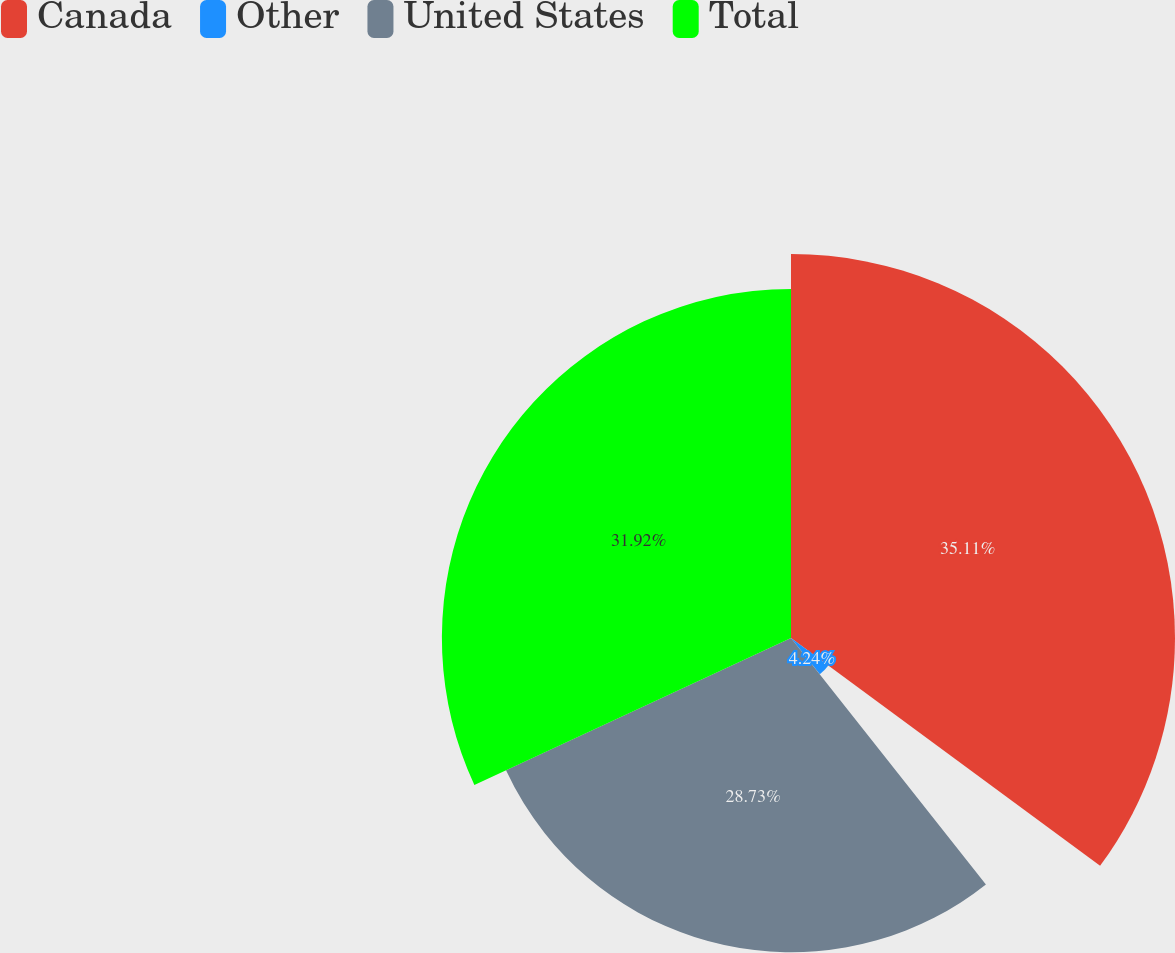Convert chart to OTSL. <chart><loc_0><loc_0><loc_500><loc_500><pie_chart><fcel>Canada<fcel>Other<fcel>United States<fcel>Total<nl><fcel>35.11%<fcel>4.24%<fcel>28.73%<fcel>31.92%<nl></chart> 